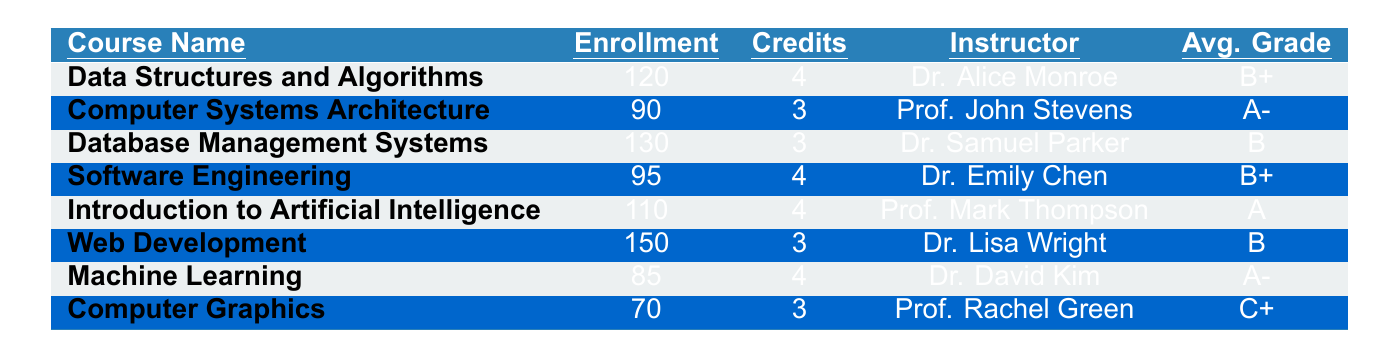What is the highest enrollment number among the courses? The highest enrollment number can be found by comparing the "Enrollment" column. The highest value is 150 for the course "Web Development".
Answer: 150 Who is the instructor for the course "Machine Learning"? The instructor for "Machine Learning" is listed in the "Instructor" column. It is Dr. David Kim.
Answer: Dr. David Kim What is the average grade for "Introduction to Artificial Intelligence"? The average grade is found in the "Avg. Grade" column. For this course, it is "A".
Answer: A How many courses have an average grade of B+ or higher? We check the "Avg. Grade" column for grades B+, A-, and A. The courses meeting this criterion are "Computer Systems Architecture", "Data Structures and Algorithms", "Introduction to Artificial Intelligence", and "Machine Learning", totaling four courses.
Answer: 4 What is the total enrollment for all courses listed? We sum the enrollment numbers: 120 + 90 + 130 + 95 + 110 + 150 + 85 + 70 = 1,000.
Answer: 1000 Is "Computer Graphics" a course with a credit value of 4? The credit value for "Computer Graphics" is listed as 3 in the "Credits" column, so the statement is false.
Answer: No Which course has the lowest average grade, and what is that grade? By reviewing the "Avg. Grade" column, we find that "Computer Graphics" has the lowest average grade of C+.
Answer: Computer Graphics, C+ What is the average number of credits across all courses? First, we sum the credits: 4 + 3 + 3 + 4 + 4 + 3 + 4 + 3 = 28, then divide by the number of courses (8) to get an average of 28/8 = 3.5.
Answer: 3.5 How many courses have more than 100 students enrolled? Checking the "Enrollment" column, the courses are: "Data Structures and Algorithms" (120), "Database Management Systems" (130), "Introduction to Artificial Intelligence" (110), and "Web Development" (150) - a total of four courses.
Answer: 4 Is "Software Engineering" offered by Dr. Emily Chen? The instructor listed for "Software Engineering" is indeed Dr. Emily Chen, making this statement true.
Answer: Yes 